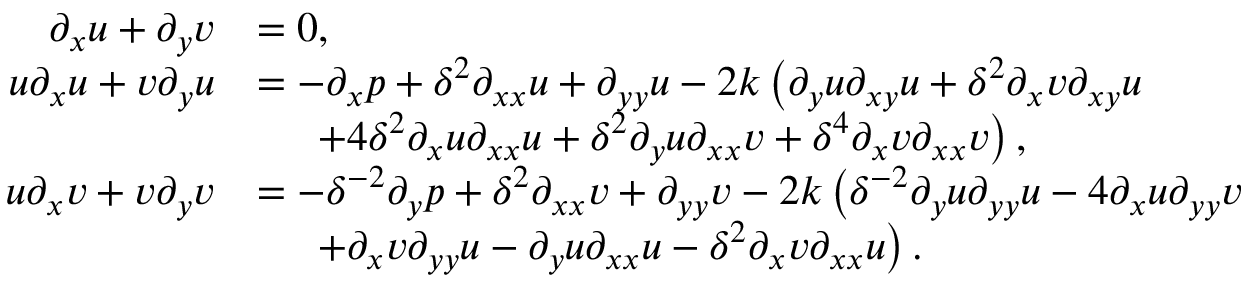<formula> <loc_0><loc_0><loc_500><loc_500>\begin{array} { r l } { \partial _ { x } u + \partial _ { y } v } & { = 0 , } \\ { u \partial _ { x } u + v \partial _ { y } u } & { = - \partial _ { x } p + \delta ^ { 2 } \partial _ { x x } u + \partial _ { y y } u - 2 k \left ( \partial _ { y } u \partial _ { x y } u + \delta ^ { 2 } \partial _ { x } v \partial _ { x y } u } \\ & { \quad + 4 \delta ^ { 2 } \partial _ { x } u \partial _ { x x } u + \delta ^ { 2 } \partial _ { y } u \partial _ { x x } v + \delta ^ { 4 } \partial _ { x } v \partial _ { x x } v \right ) , } \\ { u \partial _ { x } v + v \partial _ { y } v } & { = - \delta ^ { - 2 } \partial _ { y } p + \delta ^ { 2 } \partial _ { x x } v + \partial _ { y y } v - 2 k \left ( \delta ^ { - 2 } \partial _ { y } u \partial _ { y y } u - 4 \partial _ { x } u \partial _ { y y } v } \\ & { \quad + \partial _ { x } v \partial _ { y y } u - \partial _ { y } u \partial _ { x x } u - \delta ^ { 2 } \partial _ { x } v \partial _ { x x } u \right ) . } \end{array}</formula> 